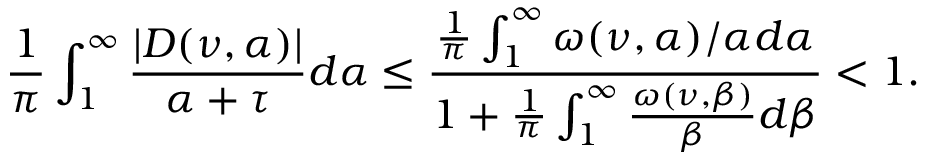<formula> <loc_0><loc_0><loc_500><loc_500>\frac { 1 } { \pi } \int _ { 1 } ^ { \infty } \frac { | D ( \nu , \alpha ) | } { \alpha + \tau } d \alpha \leq \frac { \frac { 1 } { \pi } \int _ { 1 } ^ { \infty } \omega ( \nu , \alpha ) / \alpha d \alpha } { 1 + \frac { 1 } { \pi } \int _ { 1 } ^ { \infty } \frac { \omega ( \nu , \beta ) } { \beta } d \beta } < 1 .</formula> 